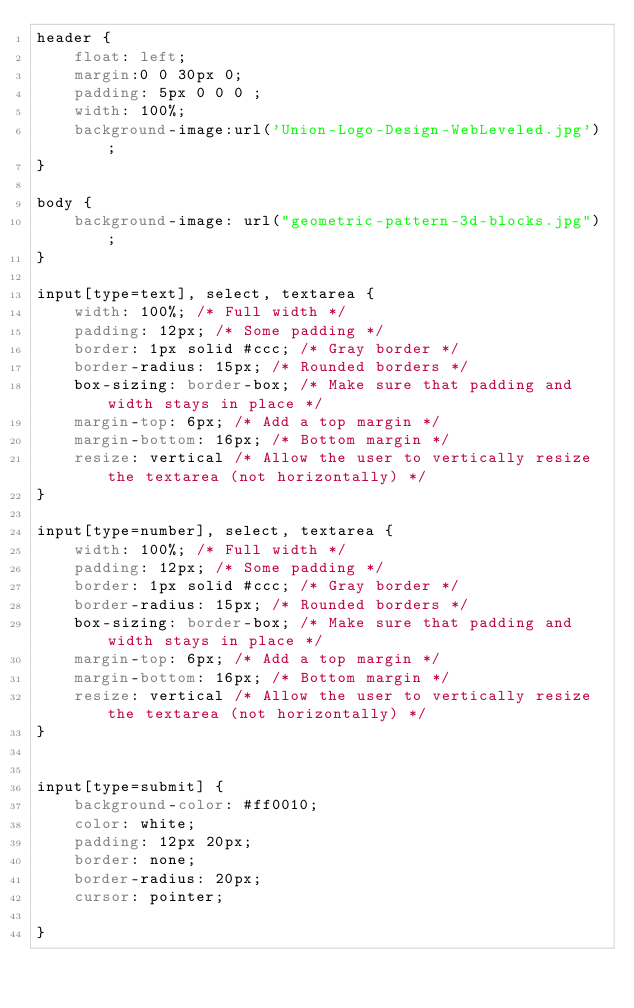<code> <loc_0><loc_0><loc_500><loc_500><_CSS_>header {
    float: left;
    margin:0 0 30px 0;
    padding: 5px 0 0 0 ;
    width: 100%;
    background-image:url('Union-Logo-Design-WebLeveled.jpg');
}

body {
    background-image: url("geometric-pattern-3d-blocks.jpg");
}

input[type=text], select, textarea {
    width: 100%; /* Full width */
    padding: 12px; /* Some padding */  
    border: 1px solid #ccc; /* Gray border */
    border-radius: 15px; /* Rounded borders */
    box-sizing: border-box; /* Make sure that padding and width stays in place */
    margin-top: 6px; /* Add a top margin */
    margin-bottom: 16px; /* Bottom margin */
    resize: vertical /* Allow the user to vertically resize the textarea (not horizontally) */
}

input[type=number], select, textarea {
    width: 100%; /* Full width */
    padding: 12px; /* Some padding */  
    border: 1px solid #ccc; /* Gray border */
    border-radius: 15px; /* Rounded borders */
    box-sizing: border-box; /* Make sure that padding and width stays in place */
    margin-top: 6px; /* Add a top margin */
    margin-bottom: 16px; /* Bottom margin */
    resize: vertical /* Allow the user to vertically resize the textarea (not horizontally) */
}


input[type=submit] {
    background-color: #ff0010;
    color: white;
    padding: 12px 20px;
    border: none;
    border-radius: 20px;
    cursor: pointer;

}

</code> 